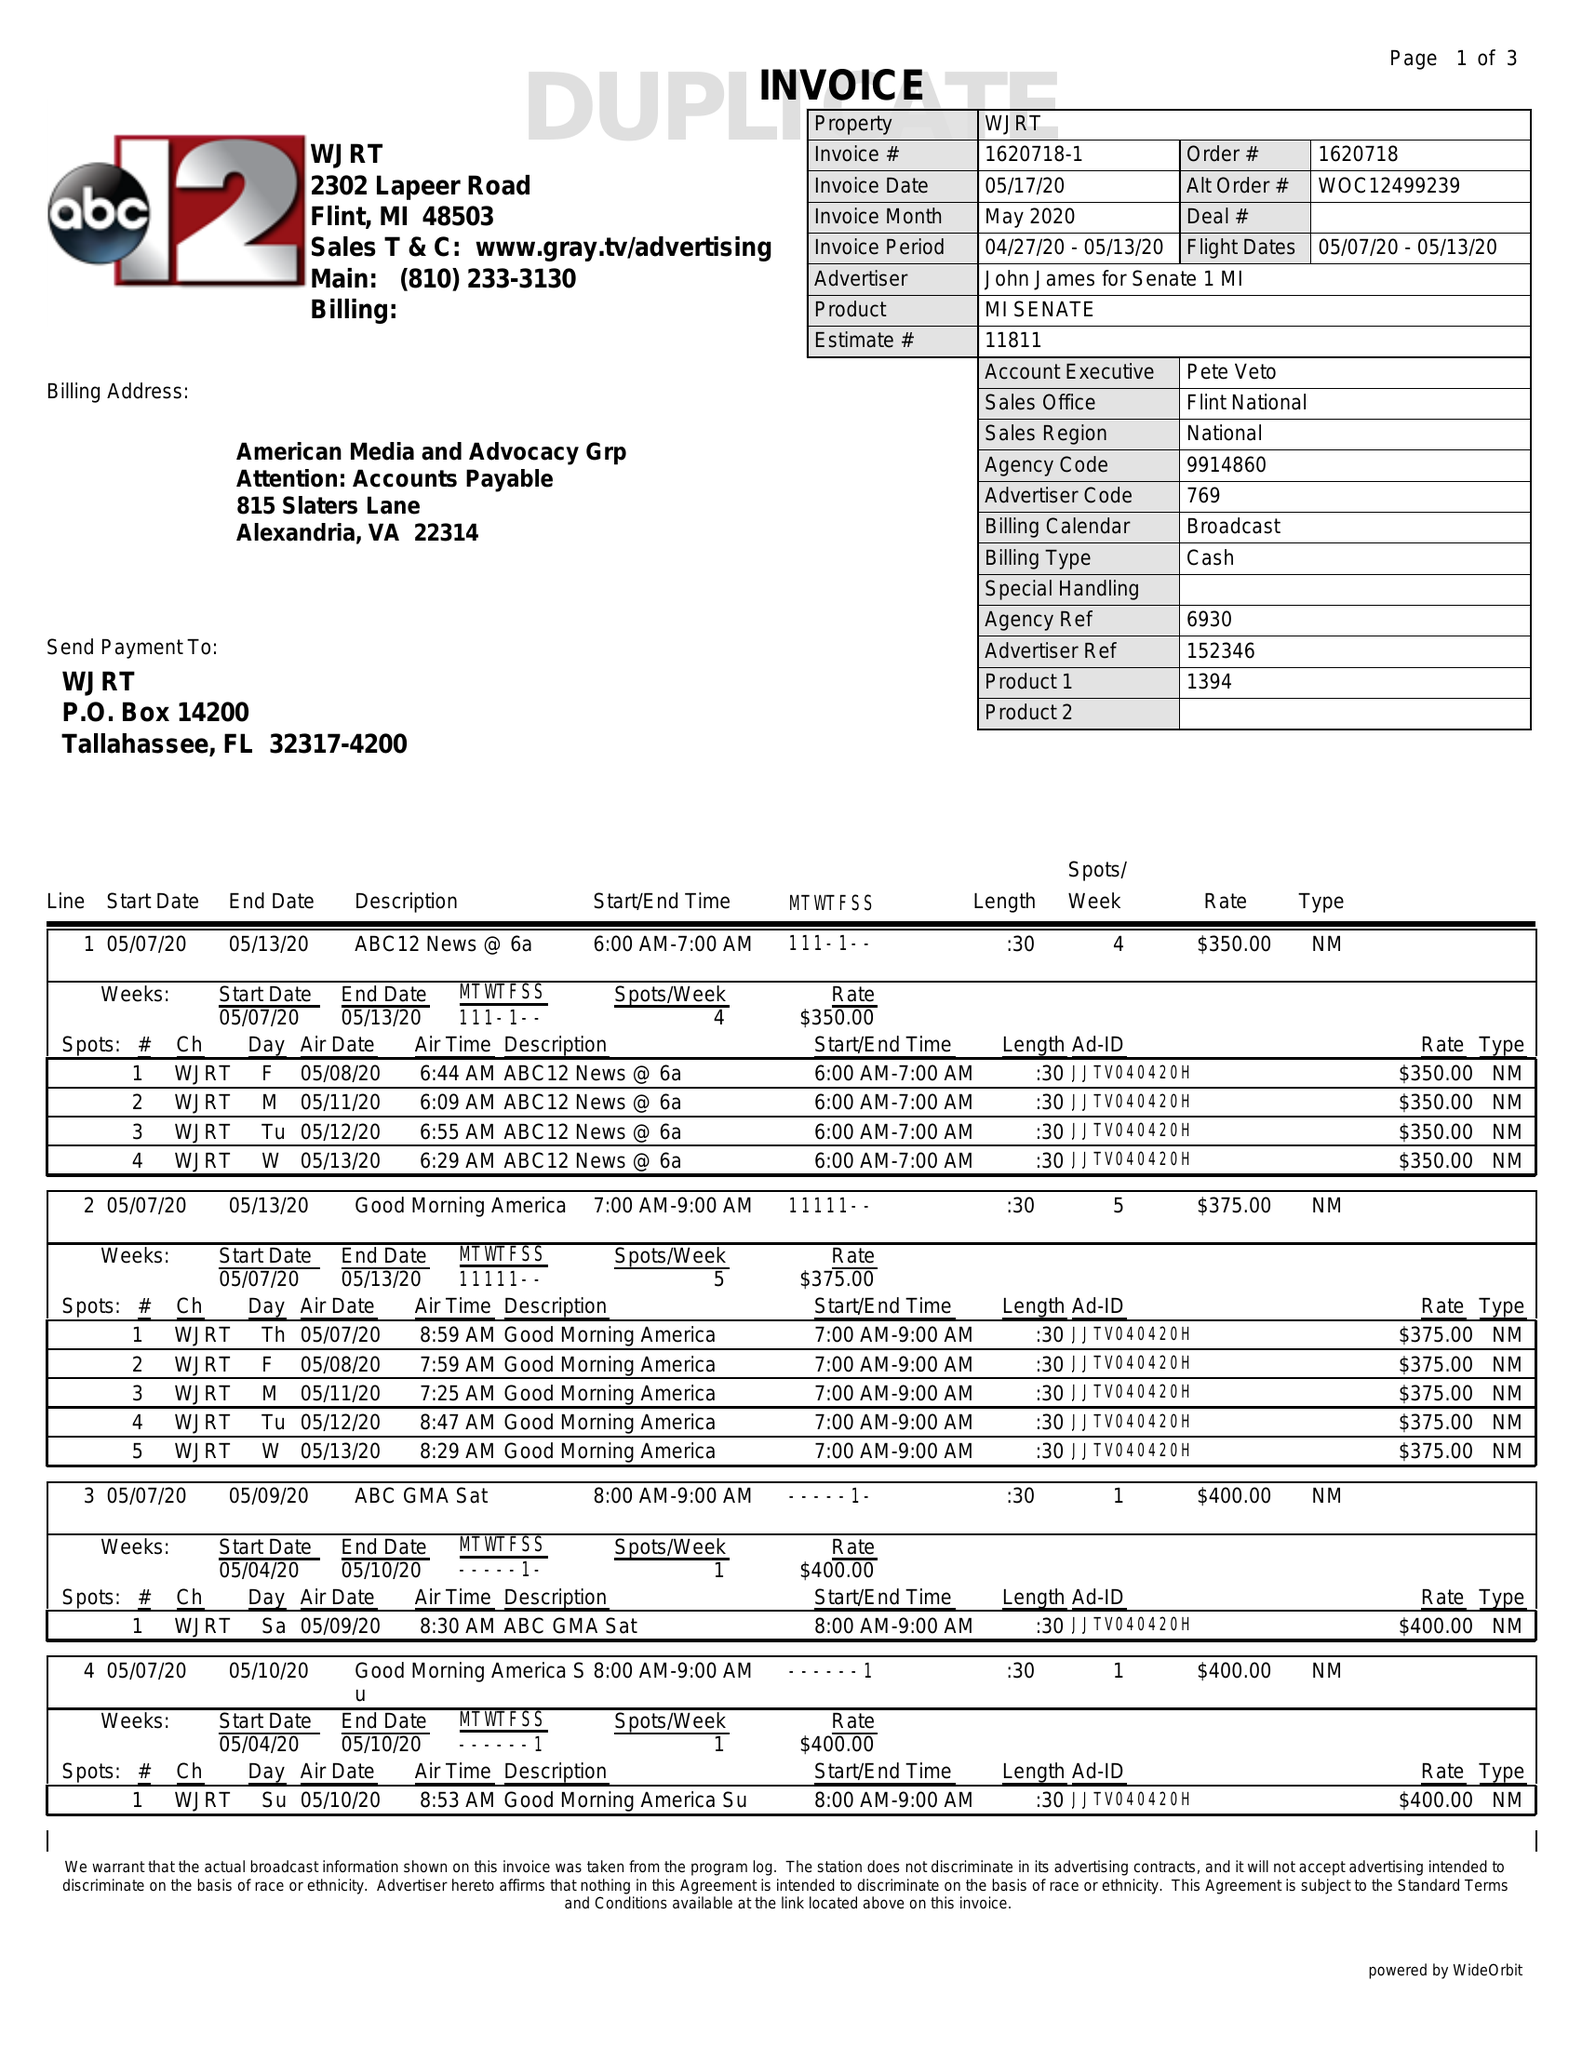What is the value for the contract_num?
Answer the question using a single word or phrase. 1620718 